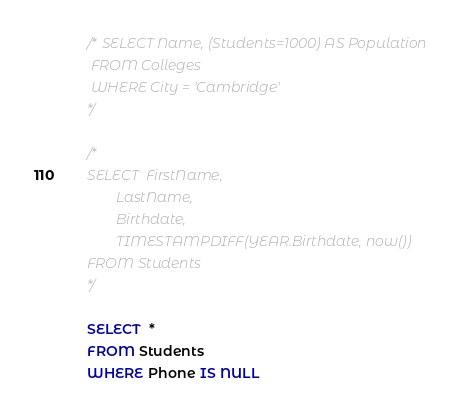<code> <loc_0><loc_0><loc_500><loc_500><_SQL_>/* SELECT Name, (Students=1000) AS Population
 FROM Colleges
 WHERE City = 'Cambridge'
*/

/*
SELECT  FirstName,
		LastName,
        Birthdate,
        TIMESTAMPDIFF(YEAR.Birthdate, now())
FROM Students
*/

SELECT  *
FROM Students
WHERE Phone IS NULL

</code> 